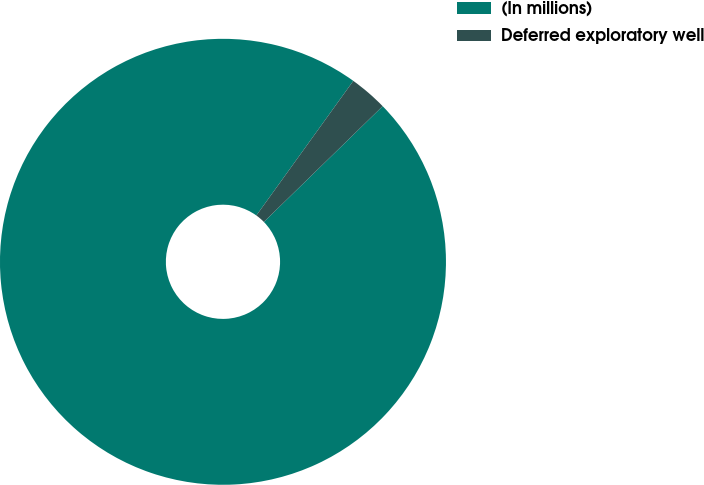<chart> <loc_0><loc_0><loc_500><loc_500><pie_chart><fcel>(In millions)<fcel>Deferred exploratory well<nl><fcel>97.23%<fcel>2.77%<nl></chart> 